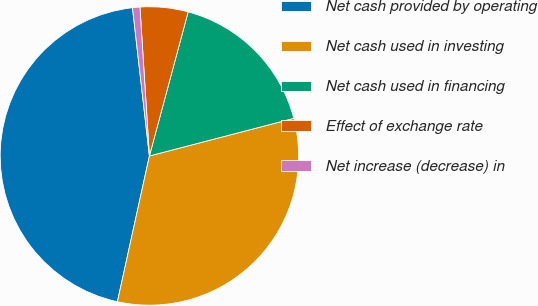Convert chart. <chart><loc_0><loc_0><loc_500><loc_500><pie_chart><fcel>Net cash provided by operating<fcel>Net cash used in investing<fcel>Net cash used in financing<fcel>Effect of exchange rate<fcel>Net increase (decrease) in<nl><fcel>44.75%<fcel>32.5%<fcel>16.76%<fcel>5.19%<fcel>0.8%<nl></chart> 